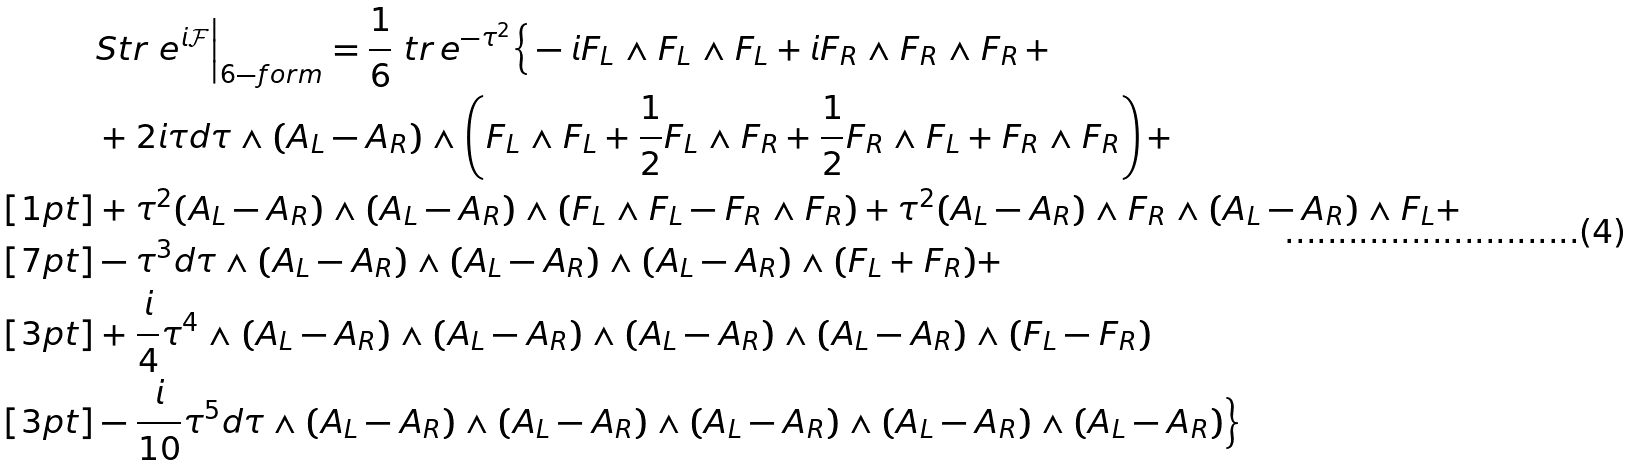Convert formula to latex. <formula><loc_0><loc_0><loc_500><loc_500>& S t r \ e ^ { i \mathcal { F } } \Big | _ { 6 - f o r m } = \frac { 1 } { 6 } \ t r \, e ^ { - \tau ^ { 2 } } \Big \{ - i F _ { L } \wedge F _ { L } \wedge F _ { L } + i F _ { R } \wedge F _ { R } \wedge F _ { R } \, + \\ & + 2 i \tau d \tau \wedge ( A _ { L } - A _ { R } ) \wedge \left ( F _ { L } \wedge F _ { L } + \frac { 1 } { 2 } F _ { L } \wedge F _ { R } + \frac { 1 } { 2 } F _ { R } \wedge F _ { L } + F _ { R } \wedge F _ { R } \right ) + \\ [ 1 p t ] & + \tau ^ { 2 } ( A _ { L } - A _ { R } ) \wedge ( A _ { L } - A _ { R } ) \wedge ( F _ { L } \wedge F _ { L } - F _ { R } \wedge F _ { R } ) + \tau ^ { 2 } ( A _ { L } - A _ { R } ) \wedge F _ { R } \wedge ( A _ { L } - A _ { R } ) \wedge F _ { L } + \\ [ 7 p t ] & - \tau ^ { 3 } d \tau \wedge ( A _ { L } - A _ { R } ) \wedge ( A _ { L } - A _ { R } ) \wedge ( A _ { L } - A _ { R } ) \wedge ( F _ { L } + F _ { R } ) + \\ [ 3 p t ] & + \frac { i } { 4 } \tau ^ { 4 } \wedge ( A _ { L } - A _ { R } ) \wedge ( A _ { L } - A _ { R } ) \wedge ( A _ { L } - A _ { R } ) \wedge ( A _ { L } - A _ { R } ) \wedge ( F _ { L } - F _ { R } ) \\ [ 3 p t ] & - \frac { i } { 1 0 } \tau ^ { 5 } d \tau \wedge ( A _ { L } - A _ { R } ) \wedge ( A _ { L } - A _ { R } ) \wedge ( A _ { L } - A _ { R } ) \wedge ( A _ { L } - A _ { R } ) \wedge ( A _ { L } - A _ { R } ) \Big \}</formula> 